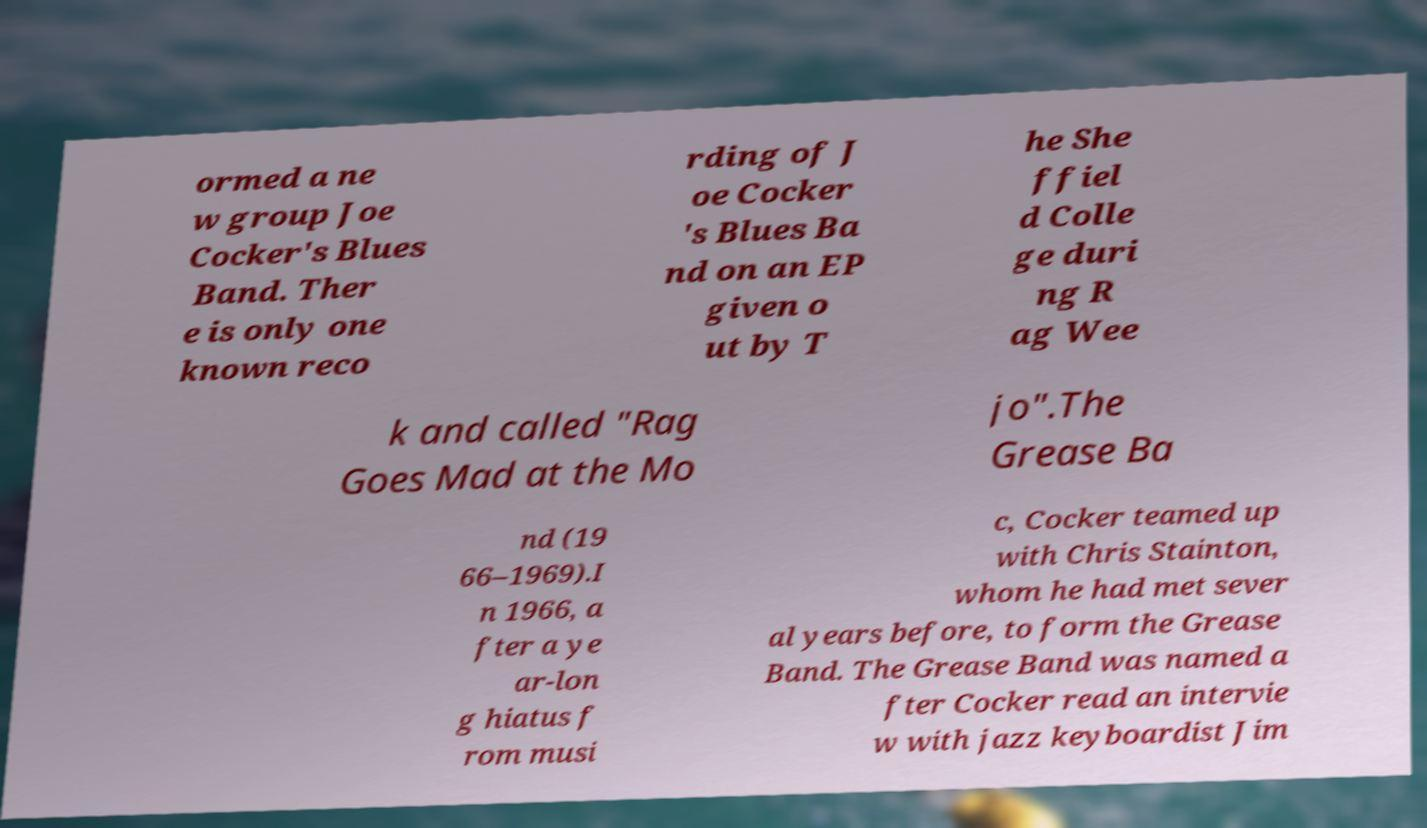For documentation purposes, I need the text within this image transcribed. Could you provide that? ormed a ne w group Joe Cocker's Blues Band. Ther e is only one known reco rding of J oe Cocker 's Blues Ba nd on an EP given o ut by T he She ffiel d Colle ge duri ng R ag Wee k and called "Rag Goes Mad at the Mo jo".The Grease Ba nd (19 66–1969).I n 1966, a fter a ye ar-lon g hiatus f rom musi c, Cocker teamed up with Chris Stainton, whom he had met sever al years before, to form the Grease Band. The Grease Band was named a fter Cocker read an intervie w with jazz keyboardist Jim 